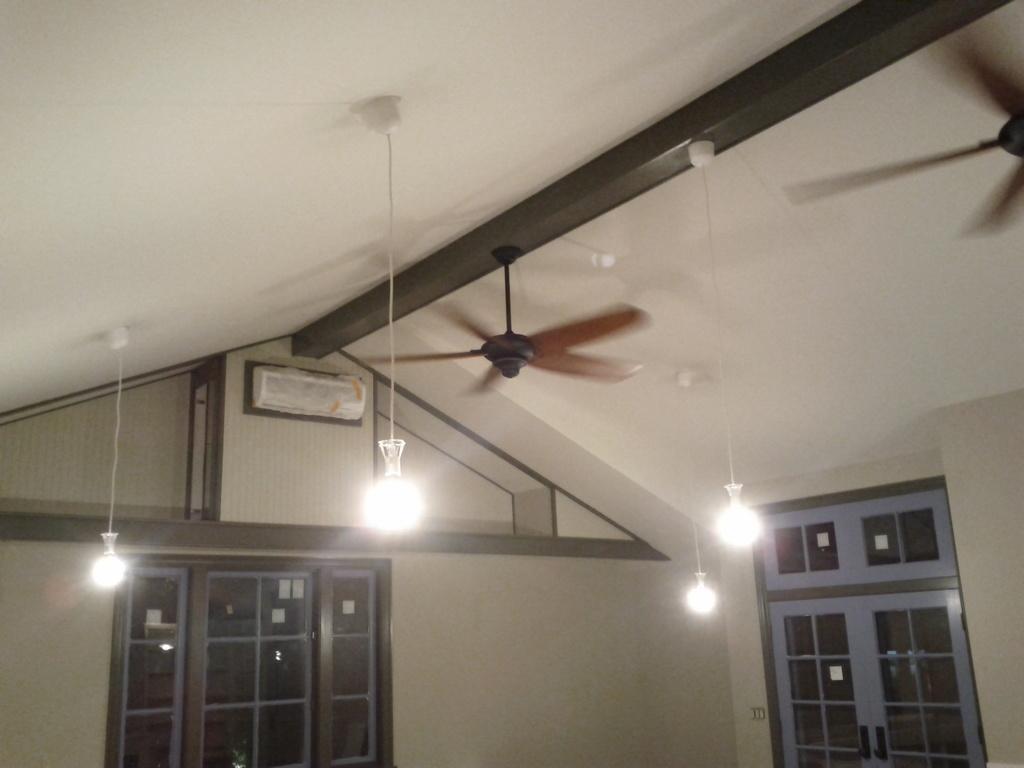Please provide a concise description of this image. In this image, we can see lights hanging from the ceiling. There is a fan in the middle of the image. There is a window in the bottom left of the image. There is a door in the bottom right of the image. 